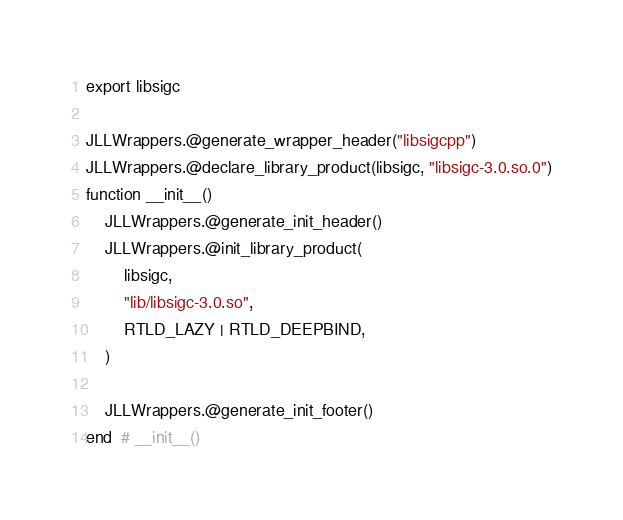Convert code to text. <code><loc_0><loc_0><loc_500><loc_500><_Julia_>export libsigc

JLLWrappers.@generate_wrapper_header("libsigcpp")
JLLWrappers.@declare_library_product(libsigc, "libsigc-3.0.so.0")
function __init__()
    JLLWrappers.@generate_init_header()
    JLLWrappers.@init_library_product(
        libsigc,
        "lib/libsigc-3.0.so",
        RTLD_LAZY | RTLD_DEEPBIND,
    )

    JLLWrappers.@generate_init_footer()
end  # __init__()
</code> 